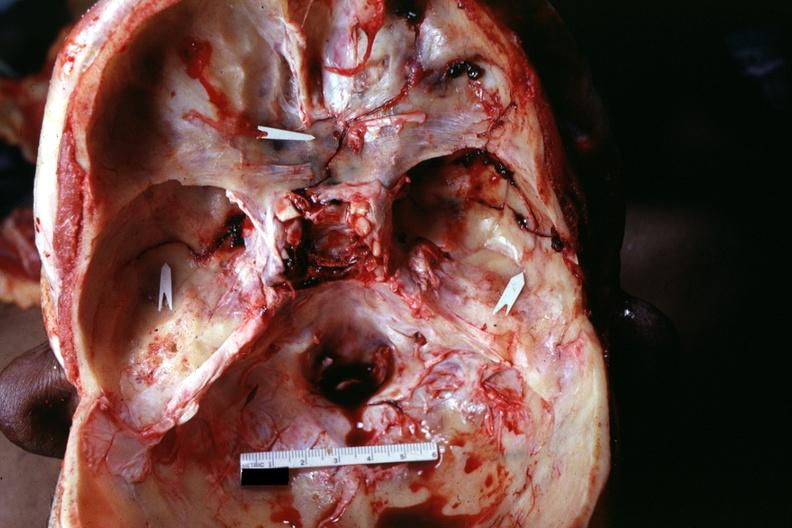what is present?
Answer the question using a single word or phrase. Bone 